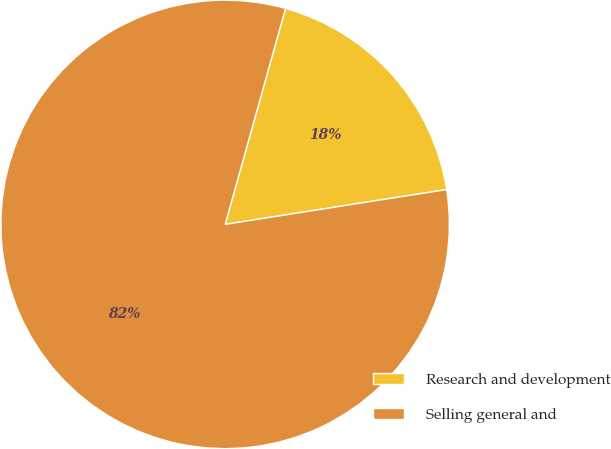Convert chart. <chart><loc_0><loc_0><loc_500><loc_500><pie_chart><fcel>Research and development<fcel>Selling general and<nl><fcel>18.18%<fcel>81.82%<nl></chart> 